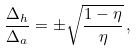<formula> <loc_0><loc_0><loc_500><loc_500>\frac { { \Delta } _ { h } } { { \Delta } _ { a } } = \pm \sqrt { \frac { 1 - \eta } { \eta } } \, ,</formula> 